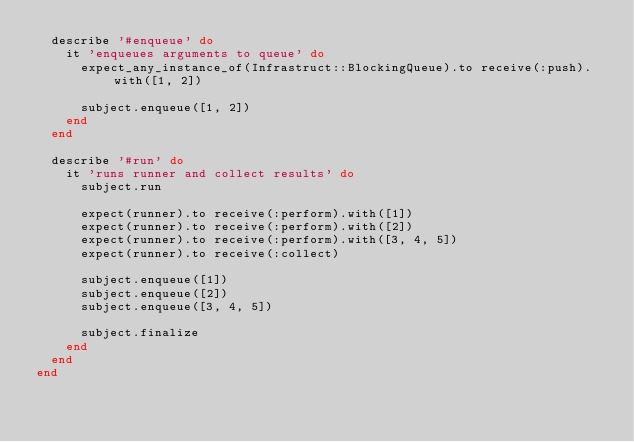Convert code to text. <code><loc_0><loc_0><loc_500><loc_500><_Ruby_>  describe '#enqueue' do
    it 'enqueues arguments to queue' do
      expect_any_instance_of(Infrastruct::BlockingQueue).to receive(:push).with([1, 2])

      subject.enqueue([1, 2])
    end
  end

  describe '#run' do
    it 'runs runner and collect results' do
      subject.run

      expect(runner).to receive(:perform).with([1])
      expect(runner).to receive(:perform).with([2])
      expect(runner).to receive(:perform).with([3, 4, 5])
      expect(runner).to receive(:collect)

      subject.enqueue([1])
      subject.enqueue([2])
      subject.enqueue([3, 4, 5])

      subject.finalize
    end
  end
end
</code> 